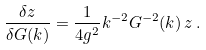<formula> <loc_0><loc_0><loc_500><loc_500>\frac { \delta z } { \delta G ( k ) } = \frac { 1 } { 4 g ^ { 2 } } k ^ { - 2 } G ^ { - 2 } ( k ) \, z \, .</formula> 